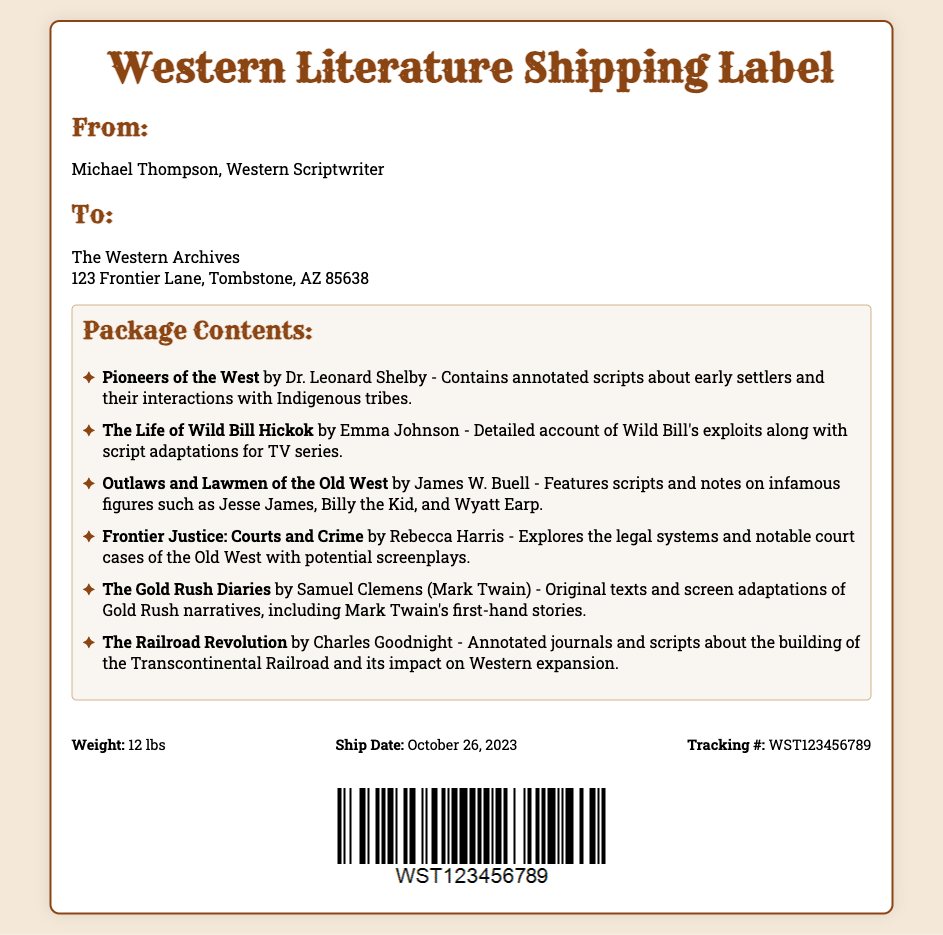What is the sender's name? The sender's name is listed at the top of the document as Michael Thompson.
Answer: Michael Thompson What is the address of the receiver? The document provides the full address of the receiver as The Western Archives, 123 Frontier Lane, Tombstone, AZ 85638.
Answer: The Western Archives, 123 Frontier Lane, Tombstone, AZ 85638 How many items are listed in the package? By counting the items in the package contents section, we identify there are six titles mentioned.
Answer: 6 What is the weight of the package? The weight of the package is stated in the footer section of the document as 12 lbs.
Answer: 12 lbs What date is the package scheduled to ship? The ship date is provided in the footer, indicating the package is scheduled to ship on October 26, 2023.
Answer: October 26, 2023 Which author wrote "The Gold Rush Diaries"? The author of "The Gold Rush Diaries" is identified in the document as Samuel Clemens, who is also known as Mark Twain.
Answer: Samuel Clemens (Mark Twain) What main theme is covered in "Outlaws and Lawmen of the Old West"? The document describes that "Outlaws and Lawmen of the Old West" features scripts and notes on infamous figures.
Answer: Infamous figures What type of document is this? This document serves as a shipping label for transporting literature scripts related to Western themes.
Answer: Shipping label 